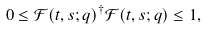Convert formula to latex. <formula><loc_0><loc_0><loc_500><loc_500>0 \leq \mathcal { F } ( t , s ; q ) ^ { \dag } \mathcal { F } ( t , s ; q ) \leq 1 ,</formula> 